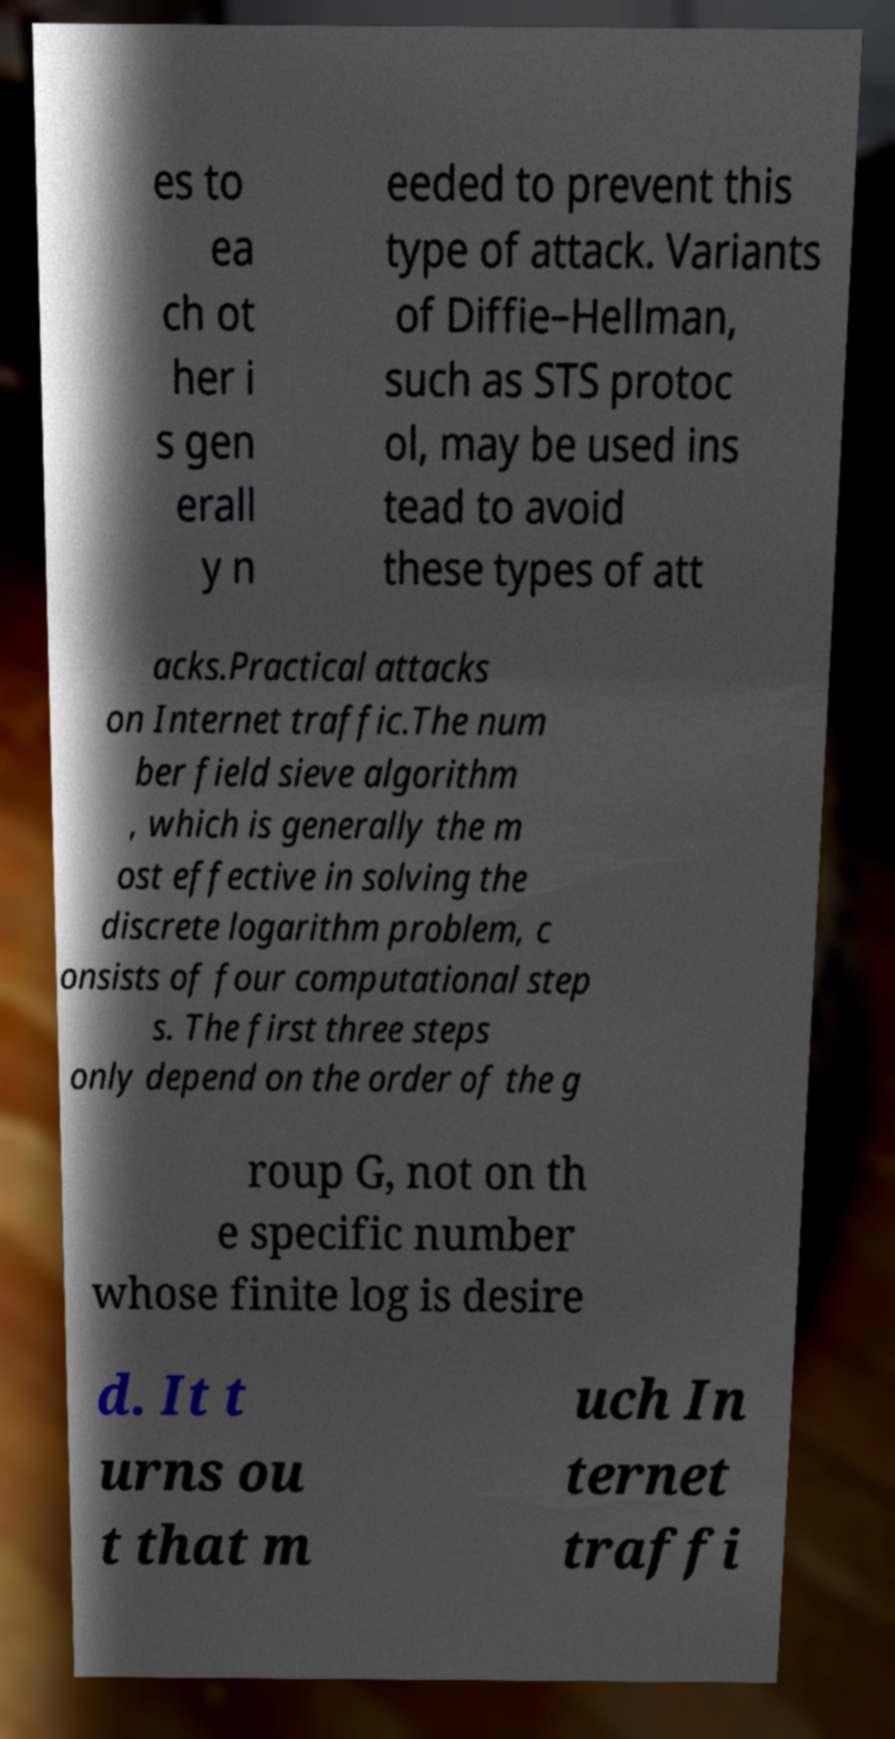Could you assist in decoding the text presented in this image and type it out clearly? es to ea ch ot her i s gen erall y n eeded to prevent this type of attack. Variants of Diffie–Hellman, such as STS protoc ol, may be used ins tead to avoid these types of att acks.Practical attacks on Internet traffic.The num ber field sieve algorithm , which is generally the m ost effective in solving the discrete logarithm problem, c onsists of four computational step s. The first three steps only depend on the order of the g roup G, not on th e specific number whose finite log is desire d. It t urns ou t that m uch In ternet traffi 